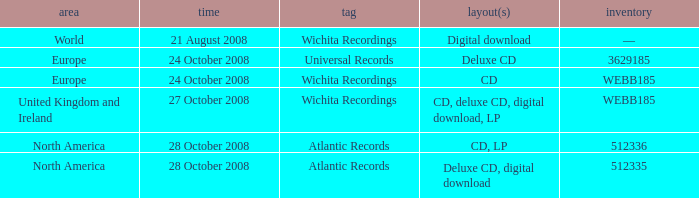Which date was associated with the release in Europe on the Wichita Recordings label? 24 October 2008. Give me the full table as a dictionary. {'header': ['area', 'time', 'tag', 'layout(s)', 'inventory'], 'rows': [['World', '21 August 2008', 'Wichita Recordings', 'Digital download', '—'], ['Europe', '24 October 2008', 'Universal Records', 'Deluxe CD', '3629185'], ['Europe', '24 October 2008', 'Wichita Recordings', 'CD', 'WEBB185'], ['United Kingdom and Ireland', '27 October 2008', 'Wichita Recordings', 'CD, deluxe CD, digital download, LP', 'WEBB185'], ['North America', '28 October 2008', 'Atlantic Records', 'CD, LP', '512336'], ['North America', '28 October 2008', 'Atlantic Records', 'Deluxe CD, digital download', '512335']]} 